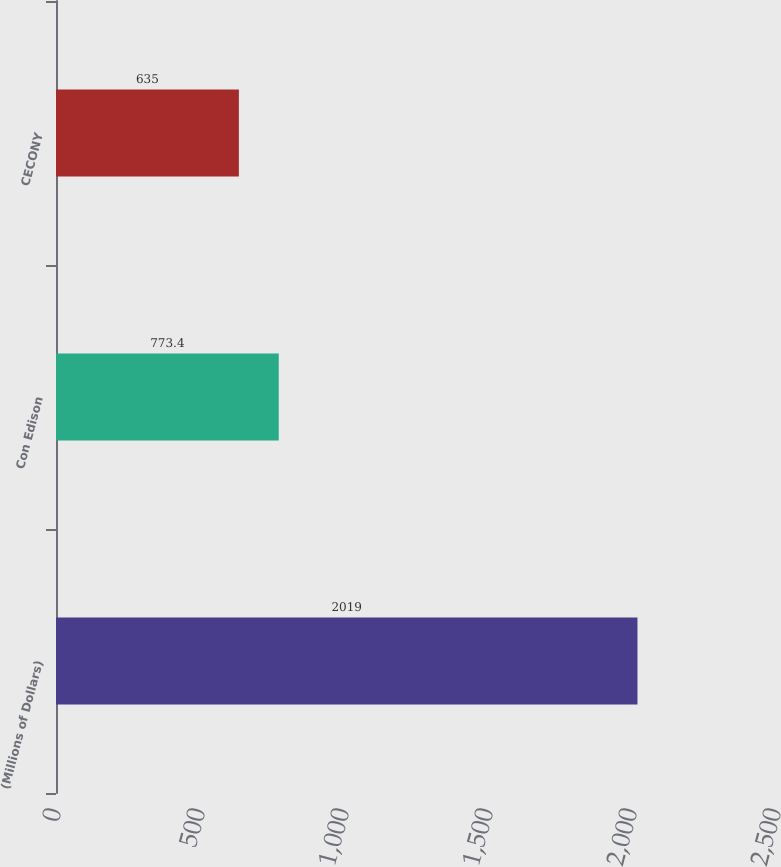Convert chart to OTSL. <chart><loc_0><loc_0><loc_500><loc_500><bar_chart><fcel>(Millions of Dollars)<fcel>Con Edison<fcel>CECONY<nl><fcel>2019<fcel>773.4<fcel>635<nl></chart> 